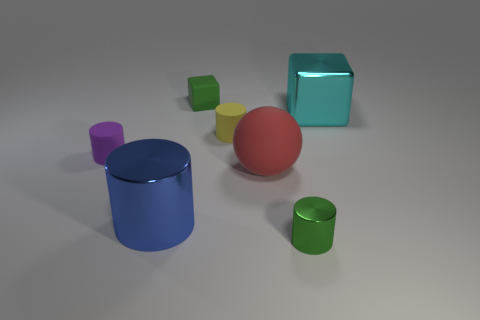Is the number of small green cylinders less than the number of tiny brown matte cylinders?
Your response must be concise. No. Are there more tiny purple metal cylinders than tiny purple objects?
Ensure brevity in your answer.  No. What number of other objects are there of the same material as the big cyan thing?
Ensure brevity in your answer.  2. What number of rubber balls are right of the big metal object that is right of the large object in front of the big red object?
Provide a short and direct response. 0. What number of rubber things are either large yellow balls or large cyan things?
Provide a short and direct response. 0. There is a matte cylinder to the right of the big shiny cylinder that is on the left side of the small block; how big is it?
Offer a very short reply. Small. Do the small cylinder left of the yellow matte thing and the small cylinder that is in front of the purple rubber thing have the same color?
Offer a very short reply. No. The thing that is to the right of the big matte object and behind the big red matte object is what color?
Your response must be concise. Cyan. Are the large blue object and the tiny purple thing made of the same material?
Make the answer very short. No. How many large objects are blue objects or red things?
Keep it short and to the point. 2. 